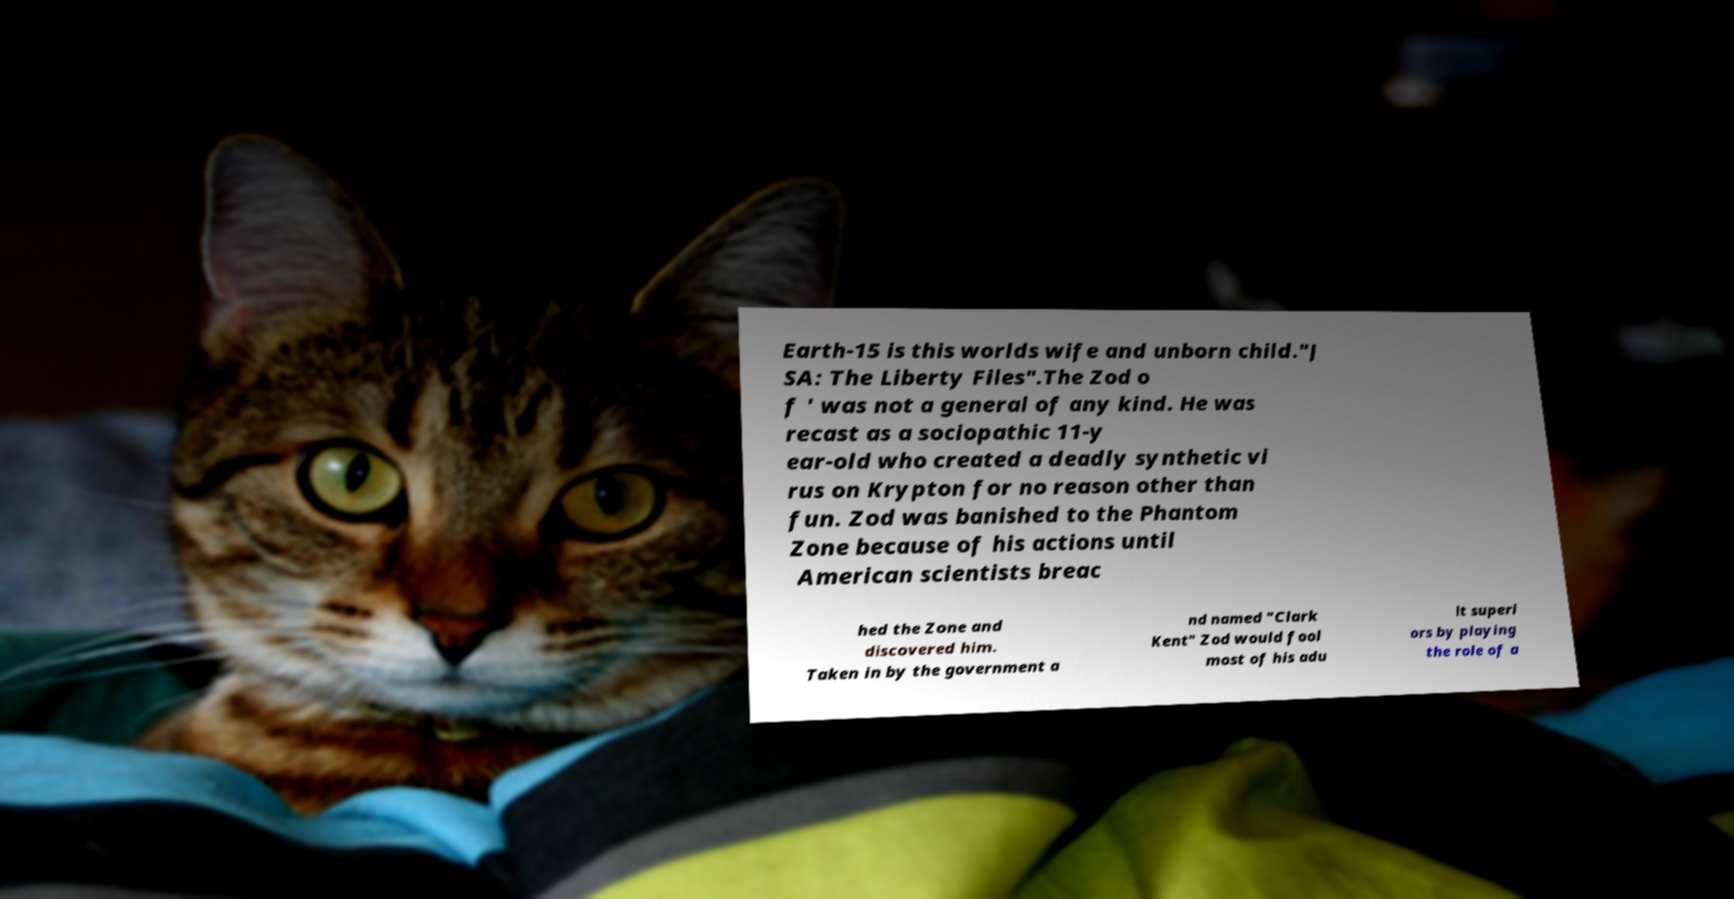There's text embedded in this image that I need extracted. Can you transcribe it verbatim? Earth-15 is this worlds wife and unborn child."J SA: The Liberty Files".The Zod o f ' was not a general of any kind. He was recast as a sociopathic 11-y ear-old who created a deadly synthetic vi rus on Krypton for no reason other than fun. Zod was banished to the Phantom Zone because of his actions until American scientists breac hed the Zone and discovered him. Taken in by the government a nd named "Clark Kent" Zod would fool most of his adu lt superi ors by playing the role of a 